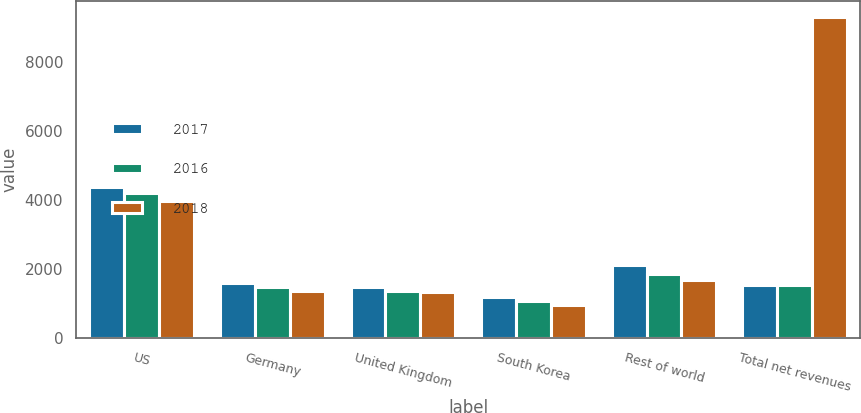<chart> <loc_0><loc_0><loc_500><loc_500><stacked_bar_chart><ecel><fcel>US<fcel>Germany<fcel>United Kingdom<fcel>South Korea<fcel>Rest of world<fcel>Total net revenues<nl><fcel>2017<fcel>4373<fcel>1591<fcel>1481<fcel>1195<fcel>2106<fcel>1536<nl><fcel>2016<fcel>4187<fcel>1464<fcel>1368<fcel>1061<fcel>1847<fcel>1536<nl><fcel>2018<fcel>3967<fcel>1359<fcel>1331<fcel>957<fcel>1684<fcel>9298<nl></chart> 